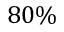<formula> <loc_0><loc_0><loc_500><loc_500>8 0 \%</formula> 